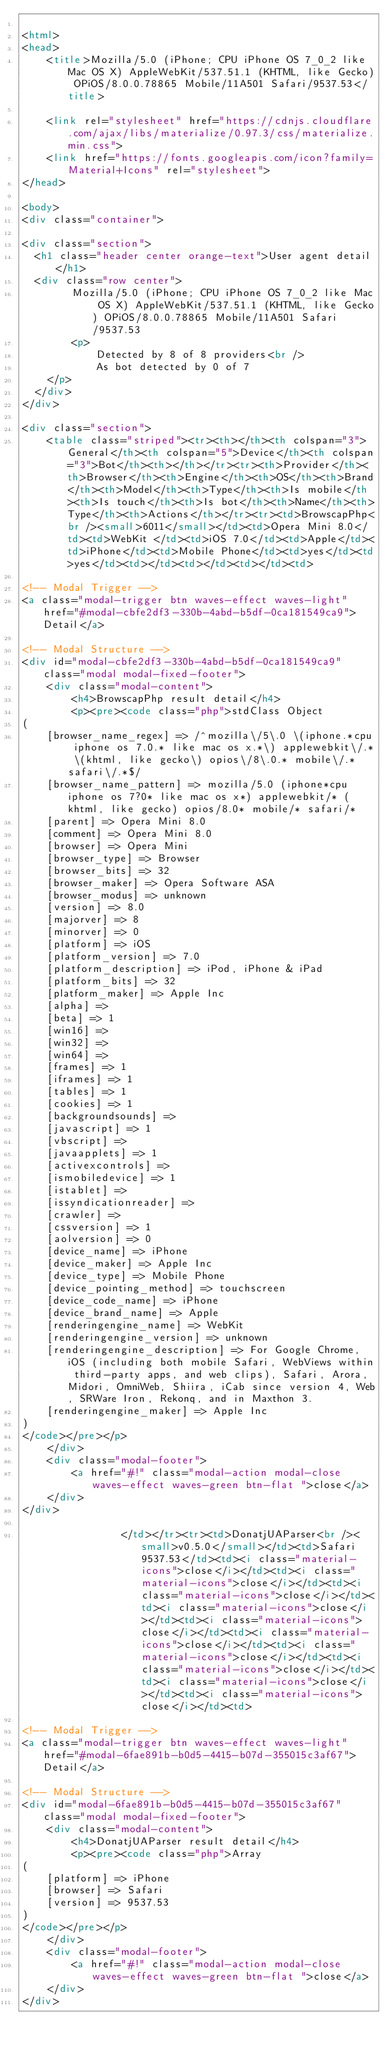<code> <loc_0><loc_0><loc_500><loc_500><_HTML_>
<html>
<head>
    <title>Mozilla/5.0 (iPhone; CPU iPhone OS 7_0_2 like Mac OS X) AppleWebKit/537.51.1 (KHTML, like Gecko) OPiOS/8.0.0.78865 Mobile/11A501 Safari/9537.53</title>
        
    <link rel="stylesheet" href="https://cdnjs.cloudflare.com/ajax/libs/materialize/0.97.3/css/materialize.min.css">
    <link href="https://fonts.googleapis.com/icon?family=Material+Icons" rel="stylesheet">
</head>
        
<body>
<div class="container">
    
<div class="section">
	<h1 class="header center orange-text">User agent detail</h1>
	<div class="row center">
        Mozilla/5.0 (iPhone; CPU iPhone OS 7_0_2 like Mac OS X) AppleWebKit/537.51.1 (KHTML, like Gecko) OPiOS/8.0.0.78865 Mobile/11A501 Safari/9537.53
        <p>
            Detected by 8 of 8 providers<br />
            As bot detected by 0 of 7
		</p>
	</div>
</div>   

<div class="section">
    <table class="striped"><tr><th></th><th colspan="3">General</th><th colspan="5">Device</th><th colspan="3">Bot</th><th></th></tr><tr><th>Provider</th><th>Browser</th><th>Engine</th><th>OS</th><th>Brand</th><th>Model</th><th>Type</th><th>Is mobile</th><th>Is touch</th><th>Is bot</th><th>Name</th><th>Type</th><th>Actions</th></tr><tr><td>BrowscapPhp<br /><small>6011</small></td><td>Opera Mini 8.0</td><td>WebKit </td><td>iOS 7.0</td><td>Apple</td><td>iPhone</td><td>Mobile Phone</td><td>yes</td><td>yes</td><td></td><td></td><td></td><td>
                
<!-- Modal Trigger -->
<a class="modal-trigger btn waves-effect waves-light" href="#modal-cbfe2df3-330b-4abd-b5df-0ca181549ca9">Detail</a>

<!-- Modal Structure -->
<div id="modal-cbfe2df3-330b-4abd-b5df-0ca181549ca9" class="modal modal-fixed-footer">
    <div class="modal-content">
        <h4>BrowscapPhp result detail</h4>
        <p><pre><code class="php">stdClass Object
(
    [browser_name_regex] => /^mozilla\/5\.0 \(iphone.*cpu iphone os 7.0.* like mac os x.*\) applewebkit\/.* \(khtml, like gecko\) opios\/8\.0.* mobile\/.* safari\/.*$/
    [browser_name_pattern] => mozilla/5.0 (iphone*cpu iphone os 7?0* like mac os x*) applewebkit/* (khtml, like gecko) opios/8.0* mobile/* safari/*
    [parent] => Opera Mini 8.0
    [comment] => Opera Mini 8.0
    [browser] => Opera Mini
    [browser_type] => Browser
    [browser_bits] => 32
    [browser_maker] => Opera Software ASA
    [browser_modus] => unknown
    [version] => 8.0
    [majorver] => 8
    [minorver] => 0
    [platform] => iOS
    [platform_version] => 7.0
    [platform_description] => iPod, iPhone & iPad
    [platform_bits] => 32
    [platform_maker] => Apple Inc
    [alpha] => 
    [beta] => 1
    [win16] => 
    [win32] => 
    [win64] => 
    [frames] => 1
    [iframes] => 1
    [tables] => 1
    [cookies] => 1
    [backgroundsounds] => 
    [javascript] => 1
    [vbscript] => 
    [javaapplets] => 1
    [activexcontrols] => 
    [ismobiledevice] => 1
    [istablet] => 
    [issyndicationreader] => 
    [crawler] => 
    [cssversion] => 1
    [aolversion] => 0
    [device_name] => iPhone
    [device_maker] => Apple Inc
    [device_type] => Mobile Phone
    [device_pointing_method] => touchscreen
    [device_code_name] => iPhone
    [device_brand_name] => Apple
    [renderingengine_name] => WebKit
    [renderingengine_version] => unknown
    [renderingengine_description] => For Google Chrome, iOS (including both mobile Safari, WebViews within third-party apps, and web clips), Safari, Arora, Midori, OmniWeb, Shiira, iCab since version 4, Web, SRWare Iron, Rekonq, and in Maxthon 3.
    [renderingengine_maker] => Apple Inc
)
</code></pre></p>
    </div>
    <div class="modal-footer">
        <a href="#!" class="modal-action modal-close waves-effect waves-green btn-flat ">close</a>
    </div>
</div>
                
                </td></tr><tr><td>DonatjUAParser<br /><small>v0.5.0</small></td><td>Safari 9537.53</td><td><i class="material-icons">close</i></td><td><i class="material-icons">close</i></td><td><i class="material-icons">close</i></td><td><i class="material-icons">close</i></td><td><i class="material-icons">close</i></td><td><i class="material-icons">close</i></td><td><i class="material-icons">close</i></td><td><i class="material-icons">close</i></td><td><i class="material-icons">close</i></td><td><i class="material-icons">close</i></td><td>
                
<!-- Modal Trigger -->
<a class="modal-trigger btn waves-effect waves-light" href="#modal-6fae891b-b0d5-4415-b07d-355015c3af67">Detail</a>

<!-- Modal Structure -->
<div id="modal-6fae891b-b0d5-4415-b07d-355015c3af67" class="modal modal-fixed-footer">
    <div class="modal-content">
        <h4>DonatjUAParser result detail</h4>
        <p><pre><code class="php">Array
(
    [platform] => iPhone
    [browser] => Safari
    [version] => 9537.53
)
</code></pre></p>
    </div>
    <div class="modal-footer">
        <a href="#!" class="modal-action modal-close waves-effect waves-green btn-flat ">close</a>
    </div>
</div>
                </code> 